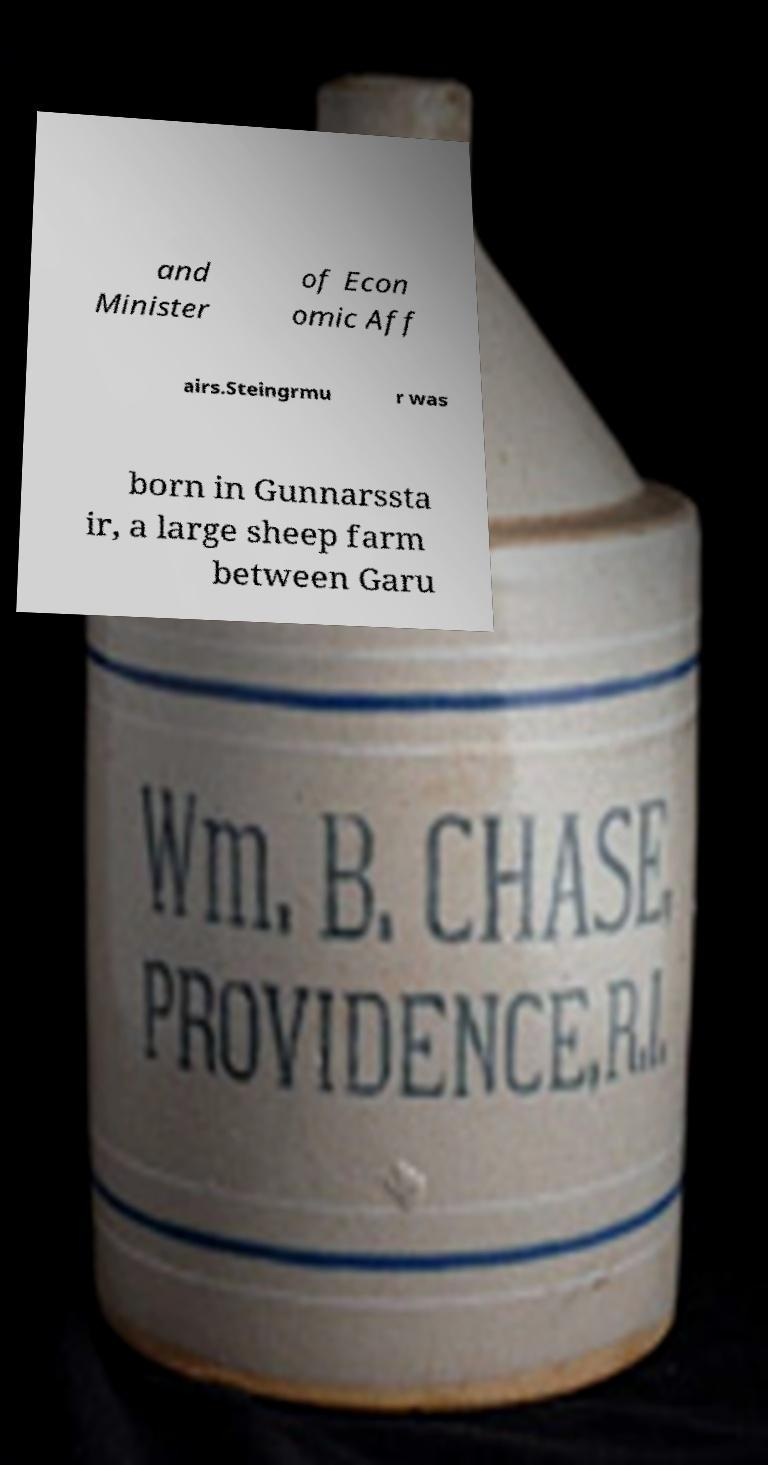What messages or text are displayed in this image? I need them in a readable, typed format. and Minister of Econ omic Aff airs.Steingrmu r was born in Gunnarssta ir, a large sheep farm between Garu 